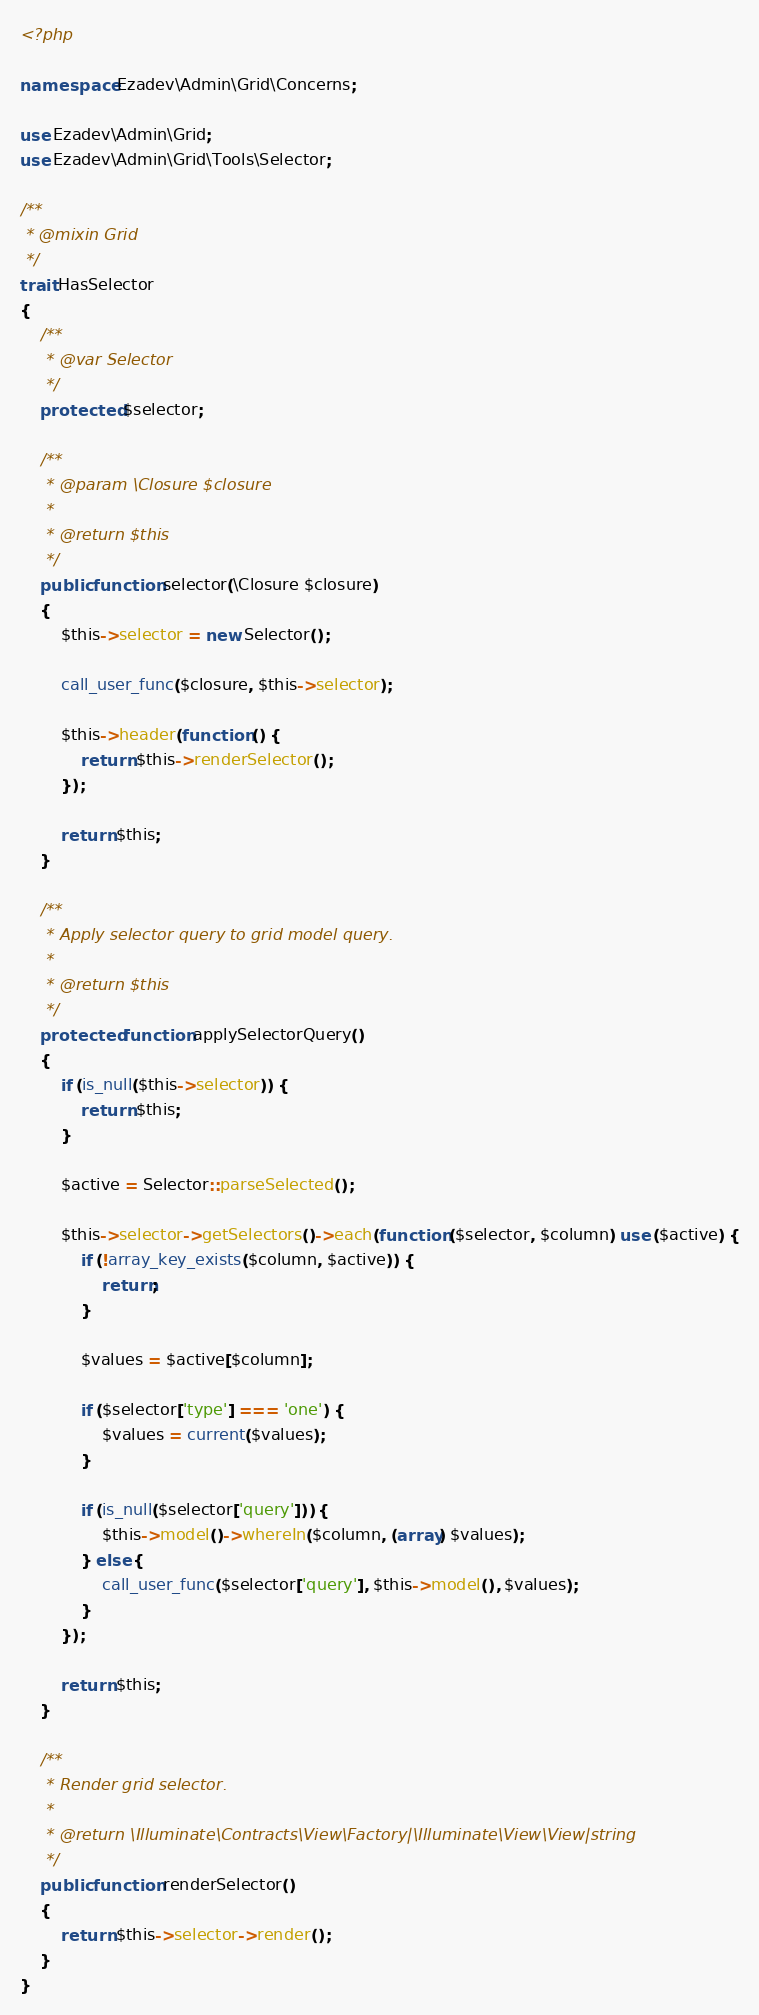<code> <loc_0><loc_0><loc_500><loc_500><_PHP_><?php

namespace Ezadev\Admin\Grid\Concerns;

use Ezadev\Admin\Grid;
use Ezadev\Admin\Grid\Tools\Selector;

/**
 * @mixin Grid
 */
trait HasSelector
{
    /**
     * @var Selector
     */
    protected $selector;

    /**
     * @param \Closure $closure
     *
     * @return $this
     */
    public function selector(\Closure $closure)
    {
        $this->selector = new Selector();

        call_user_func($closure, $this->selector);

        $this->header(function () {
            return $this->renderSelector();
        });

        return $this;
    }

    /**
     * Apply selector query to grid model query.
     *
     * @return $this
     */
    protected function applySelectorQuery()
    {
        if (is_null($this->selector)) {
            return $this;
        }

        $active = Selector::parseSelected();

        $this->selector->getSelectors()->each(function ($selector, $column) use ($active) {
            if (!array_key_exists($column, $active)) {
                return;
            }

            $values = $active[$column];

            if ($selector['type'] === 'one') {
                $values = current($values);
            }

            if (is_null($selector['query'])) {
                $this->model()->whereIn($column, (array) $values);
            } else {
                call_user_func($selector['query'], $this->model(), $values);
            }
        });

        return $this;
    }

    /**
     * Render grid selector.
     *
     * @return \Illuminate\Contracts\View\Factory|\Illuminate\View\View|string
     */
    public function renderSelector()
    {
        return $this->selector->render();
    }
}
</code> 